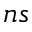<formula> <loc_0><loc_0><loc_500><loc_500>n s</formula> 